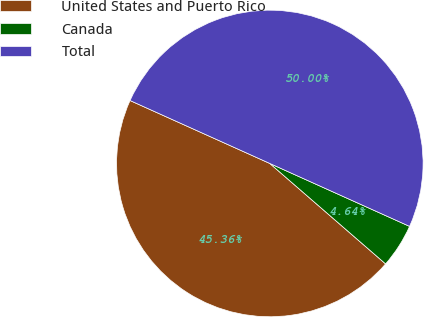<chart> <loc_0><loc_0><loc_500><loc_500><pie_chart><fcel>United States and Puerto Rico<fcel>Canada<fcel>Total<nl><fcel>45.36%<fcel>4.64%<fcel>50.0%<nl></chart> 